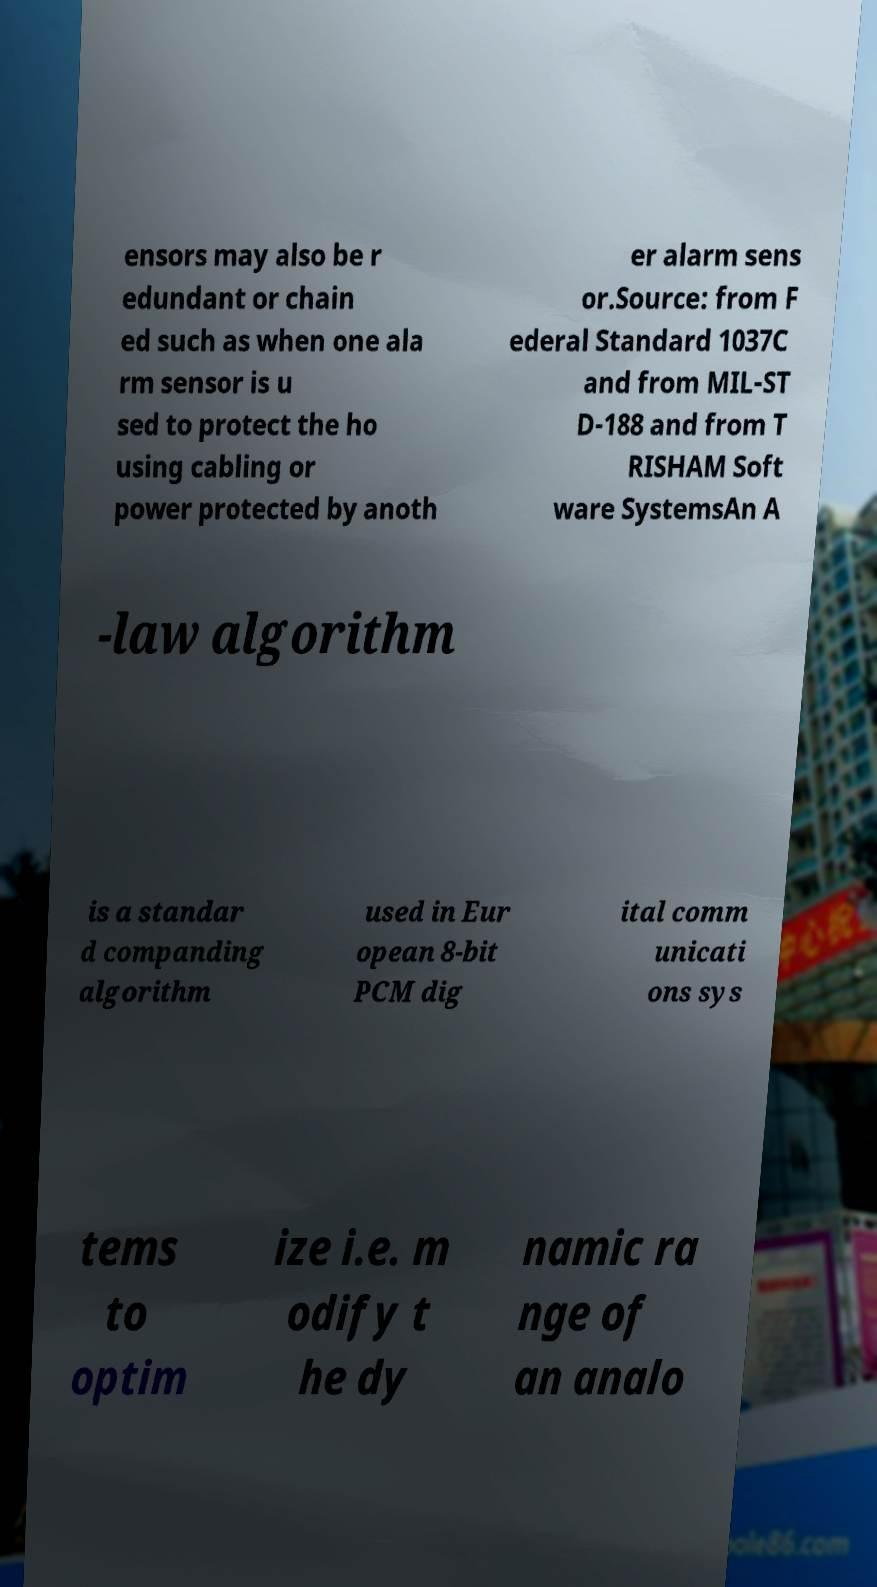I need the written content from this picture converted into text. Can you do that? ensors may also be r edundant or chain ed such as when one ala rm sensor is u sed to protect the ho using cabling or power protected by anoth er alarm sens or.Source: from F ederal Standard 1037C and from MIL-ST D-188 and from T RISHAM Soft ware SystemsAn A -law algorithm is a standar d companding algorithm used in Eur opean 8-bit PCM dig ital comm unicati ons sys tems to optim ize i.e. m odify t he dy namic ra nge of an analo 